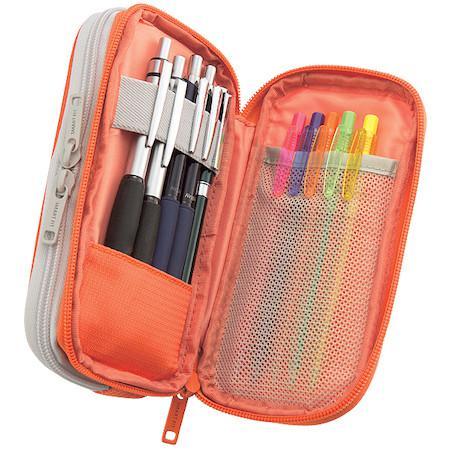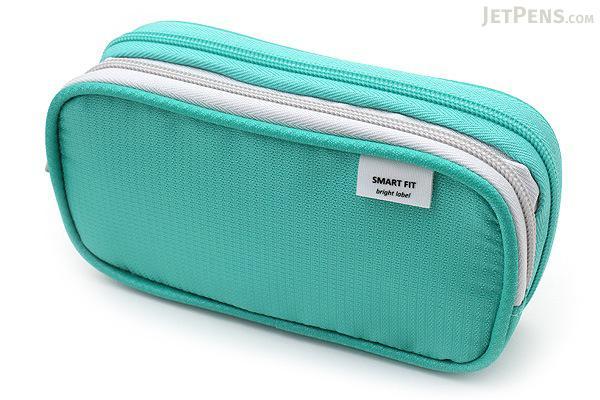The first image is the image on the left, the second image is the image on the right. Considering the images on both sides, is "There is one yellow and one black case." valid? Answer yes or no. No. The first image is the image on the left, the second image is the image on the right. Evaluate the accuracy of this statement regarding the images: "Each image includes a single pencil case, and the left image shows an open case filled with writing implements.". Is it true? Answer yes or no. Yes. 